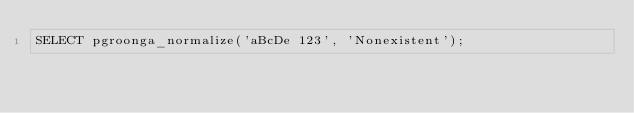<code> <loc_0><loc_0><loc_500><loc_500><_SQL_>SELECT pgroonga_normalize('aBcDe 123', 'Nonexistent');
</code> 